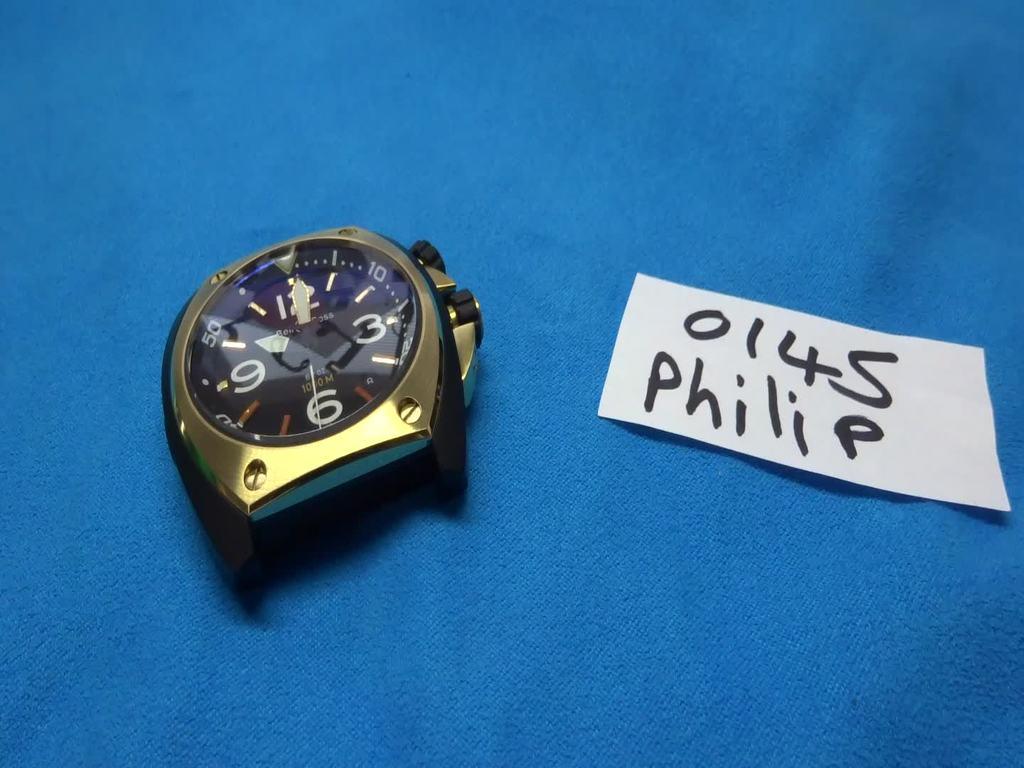What time is shown on the watch?
Your answer should be compact. 10:01. What is the name of this watch?
Your answer should be compact. Philip. 